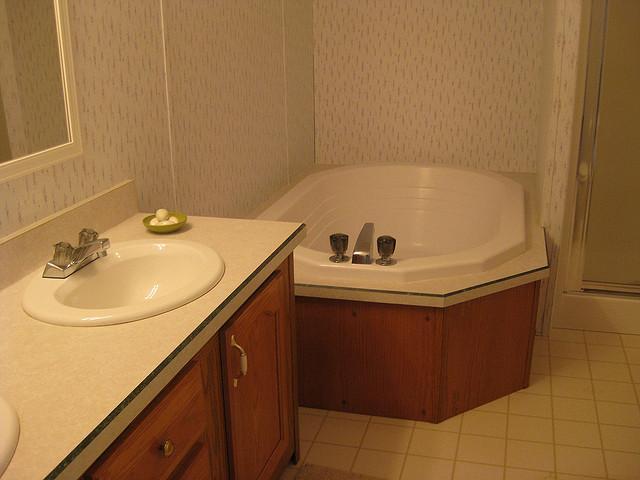How many people aren't holding their phone?
Give a very brief answer. 0. 